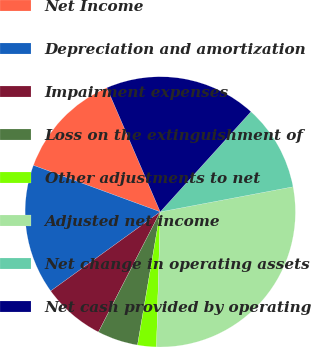Convert chart. <chart><loc_0><loc_0><loc_500><loc_500><pie_chart><fcel>Net Income<fcel>Depreciation and amortization<fcel>Impairment expenses<fcel>Loss on the extinguishment of<fcel>Other adjustments to net<fcel>Adjusted net income<fcel>Net change in operating assets<fcel>Net cash provided by operating<nl><fcel>12.94%<fcel>15.55%<fcel>7.48%<fcel>4.87%<fcel>2.25%<fcel>28.41%<fcel>10.32%<fcel>18.17%<nl></chart> 